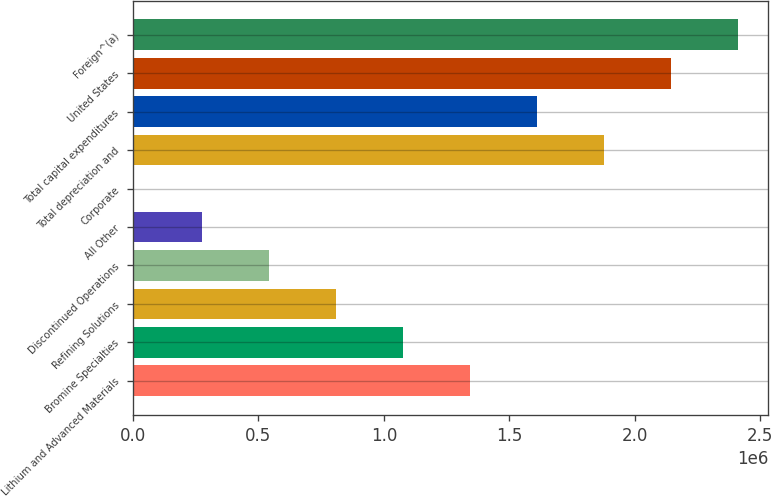Convert chart. <chart><loc_0><loc_0><loc_500><loc_500><bar_chart><fcel>Lithium and Advanced Materials<fcel>Bromine Specialties<fcel>Refining Solutions<fcel>Discontinued Operations<fcel>All Other<fcel>Corporate<fcel>Total depreciation and<fcel>Total capital expenditures<fcel>United States<fcel>Foreign^(a)<nl><fcel>1.34163e+06<fcel>1.07451e+06<fcel>807400<fcel>540285<fcel>273171<fcel>6056<fcel>1.87586e+06<fcel>1.60874e+06<fcel>2.14297e+06<fcel>2.41009e+06<nl></chart> 